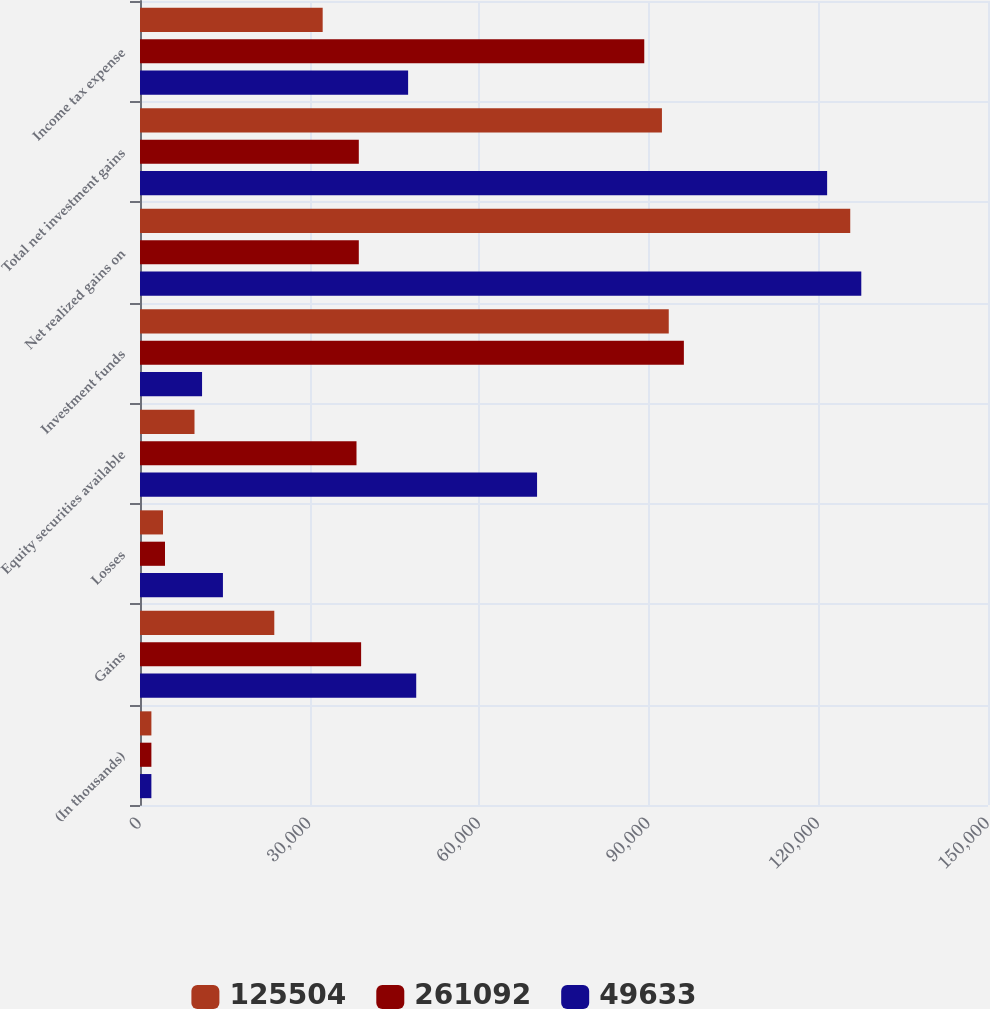Convert chart. <chart><loc_0><loc_0><loc_500><loc_500><stacked_bar_chart><ecel><fcel>(In thousands)<fcel>Gains<fcel>Losses<fcel>Equity securities available<fcel>Investment funds<fcel>Net realized gains on<fcel>Total net investment gains<fcel>Income tax expense<nl><fcel>125504<fcel>2015<fcel>23755<fcel>4065<fcel>9639<fcel>93529<fcel>125633<fcel>92324<fcel>32313<nl><fcel>261092<fcel>2014<fcel>39113<fcel>4420<fcel>38296<fcel>96204<fcel>38704.5<fcel>38704.5<fcel>89198<nl><fcel>49633<fcel>2013<fcel>48860<fcel>14670<fcel>70235<fcel>10976<fcel>127586<fcel>121544<fcel>47426<nl></chart> 